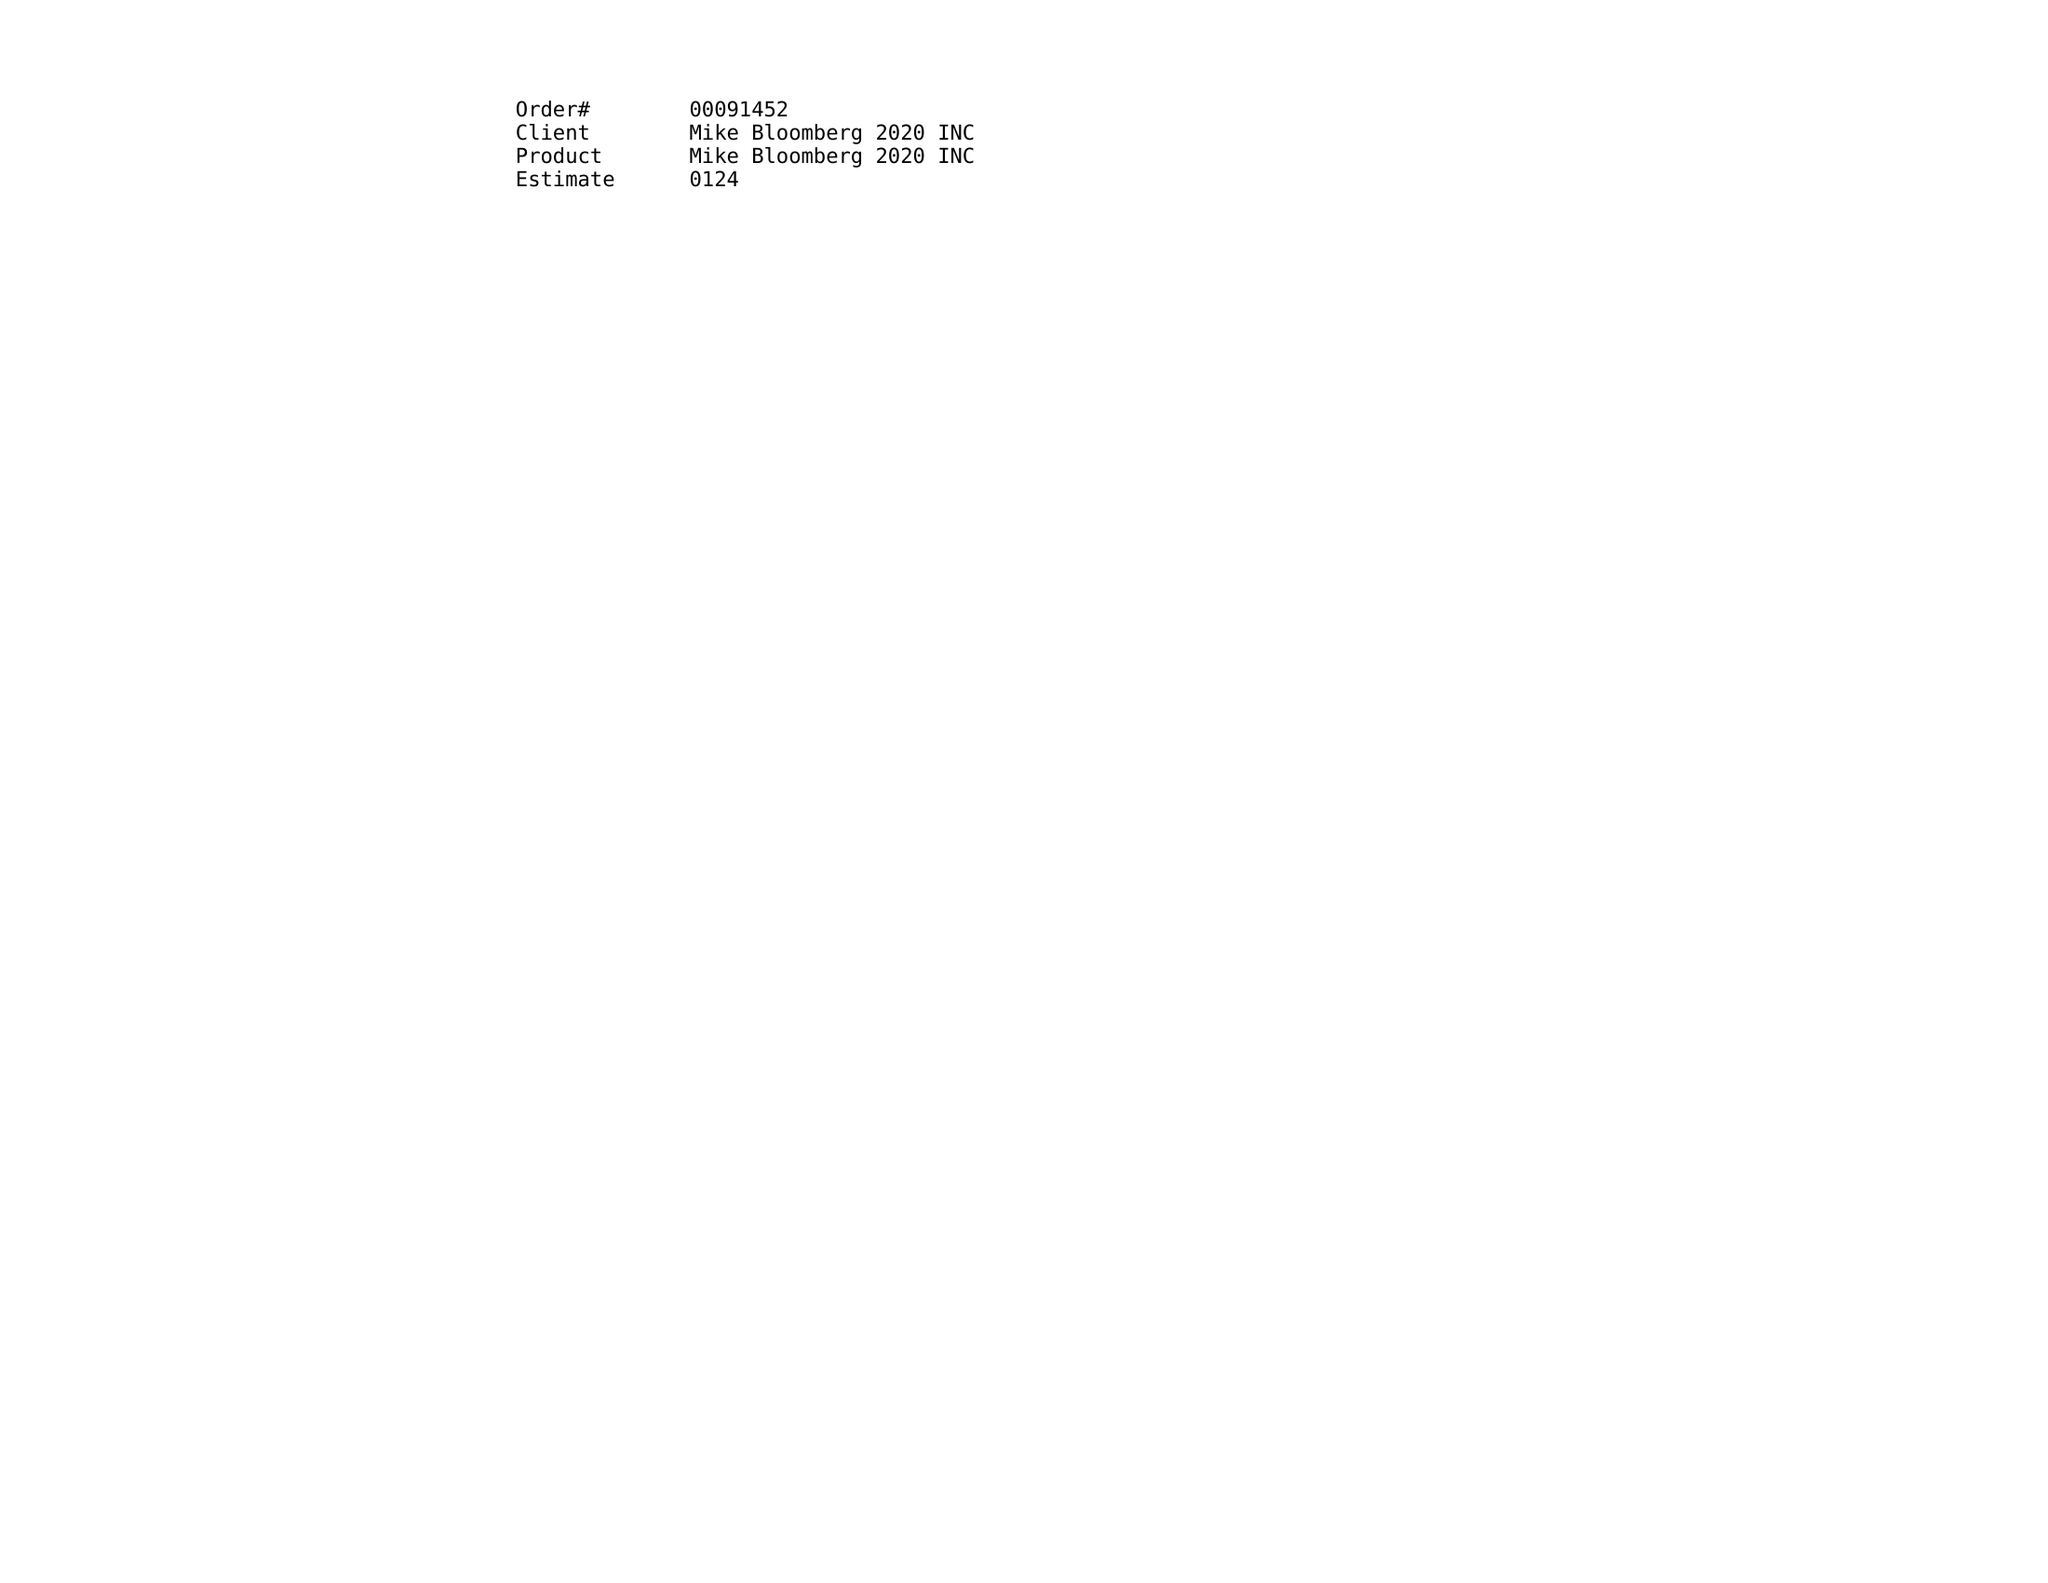What is the value for the flight_from?
Answer the question using a single word or phrase. 12/30/19 